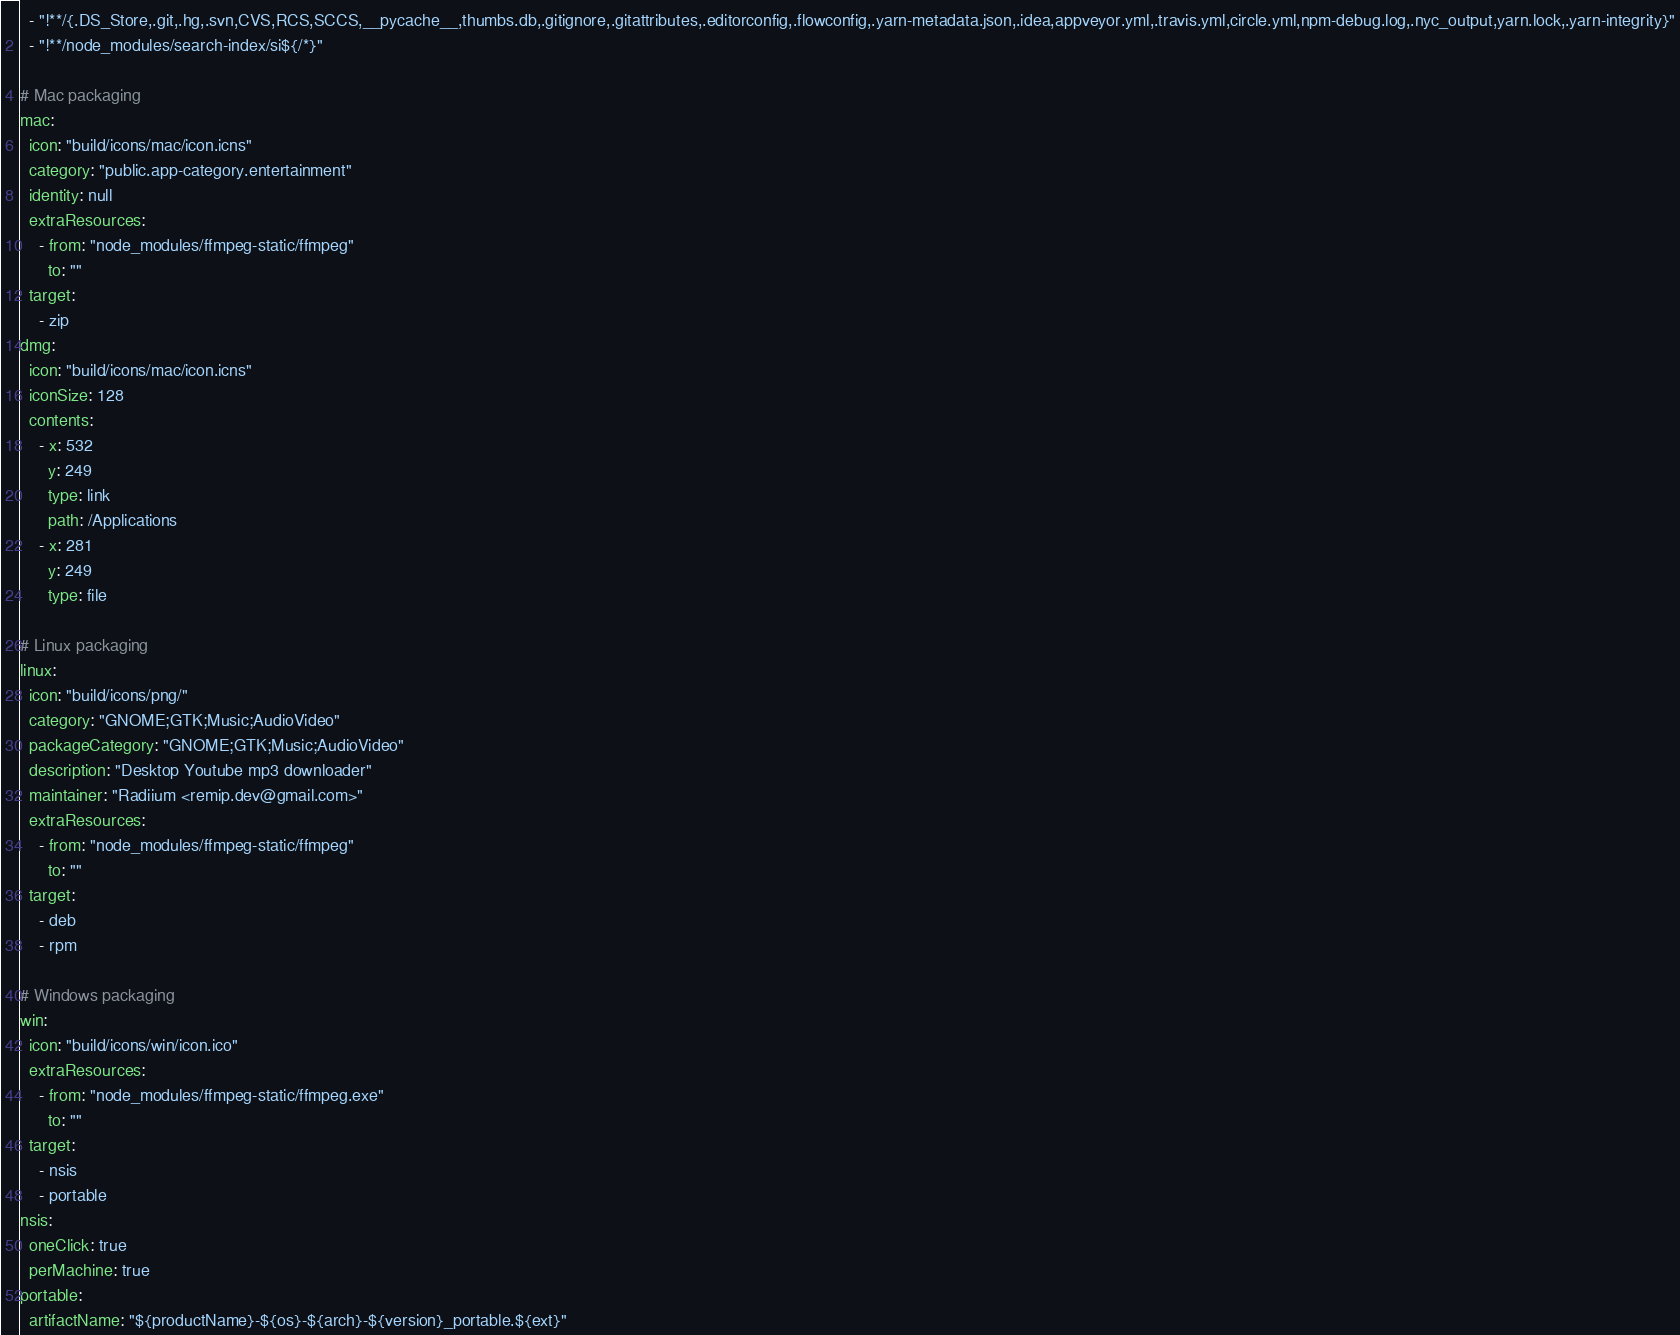<code> <loc_0><loc_0><loc_500><loc_500><_YAML_>  - "!**/{.DS_Store,.git,.hg,.svn,CVS,RCS,SCCS,__pycache__,thumbs.db,.gitignore,.gitattributes,.editorconfig,.flowconfig,.yarn-metadata.json,.idea,appveyor.yml,.travis.yml,circle.yml,npm-debug.log,.nyc_output,yarn.lock,.yarn-integrity}"
  - "!**/node_modules/search-index/si${/*}"

# Mac packaging
mac:
  icon: "build/icons/mac/icon.icns"
  category: "public.app-category.entertainment"
  identity: null
  extraResources:
    - from: "node_modules/ffmpeg-static/ffmpeg"
      to: ""
  target:
    - zip
dmg:
  icon: "build/icons/mac/icon.icns"
  iconSize: 128
  contents:
    - x: 532
      y: 249
      type: link
      path: /Applications
    - x: 281
      y: 249
      type: file

# Linux packaging
linux:
  icon: "build/icons/png/"
  category: "GNOME;GTK;Music;AudioVideo"
  packageCategory: "GNOME;GTK;Music;AudioVideo"
  description: "Desktop Youtube mp3 downloader"
  maintainer: "Radiium <remip.dev@gmail.com>"
  extraResources:
    - from: "node_modules/ffmpeg-static/ffmpeg"
      to: ""
  target:
    - deb
    - rpm

# Windows packaging
win:
  icon: "build/icons/win/icon.ico"
  extraResources:
    - from: "node_modules/ffmpeg-static/ffmpeg.exe"
      to: ""
  target:
    - nsis
    - portable
nsis:
  oneClick: true
  perMachine: true
portable:
  artifactName: "${productName}-${os}-${arch}-${version}_portable.${ext}"

</code> 